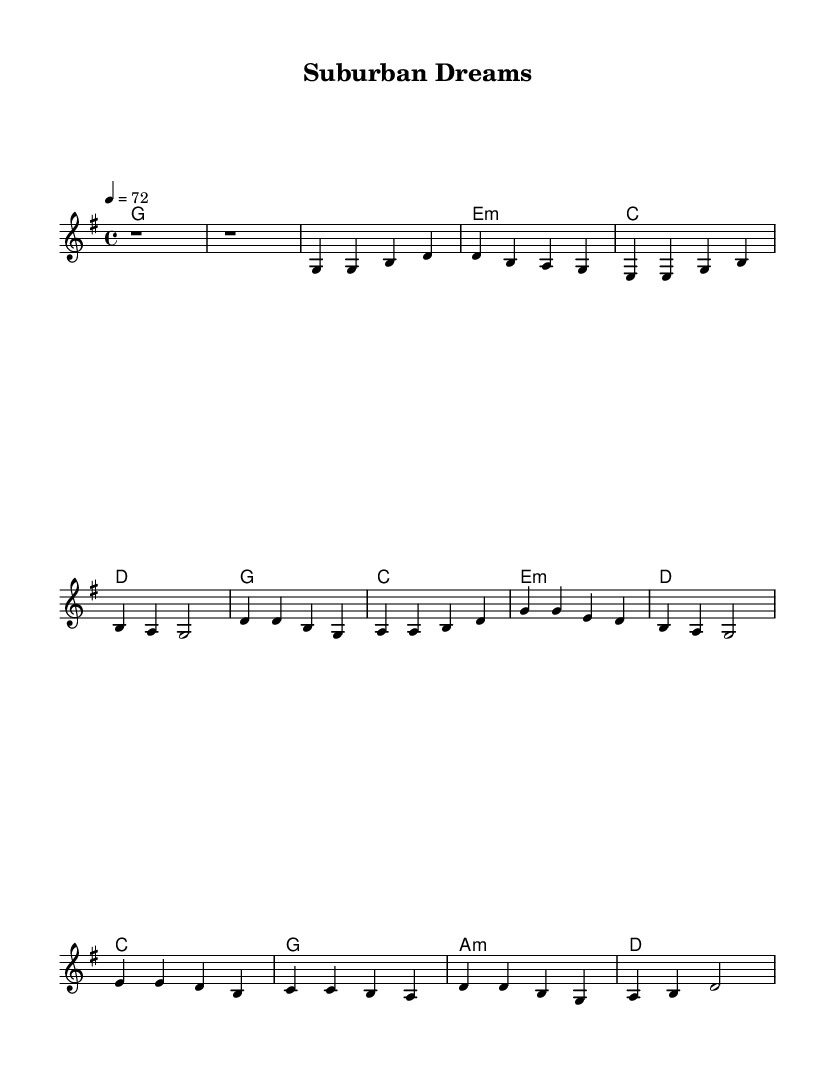what is the key signature of this music? The key signature is indicated by the presence of the G major key, which has one sharp (F#). This is seen at the beginning of the score.
Answer: G major what is the time signature of this sheet music? The time signature is determined by the notation shown at the beginning of the score, which displays 4/4. This indicates four beats per measure.
Answer: 4/4 what is the tempo marking of this piece? The tempo marking appears as 4 = 72, indicating that there are 72 beats in one minute at a quarter note count. This is also seen near the beginning of the score.
Answer: 72 which section of the music is represented by the intro? The intro is indicated by the initial two measures of rests, which is shown at the beginning of the melody.
Answer: two measures of rests how many bars are in the chorus section? To determine the number of bars in the chorus, we count the measures labeled in the music, which consists of four distinct measures written for the chorus.
Answer: 4 what is the relationship between the first and last chords in the song? The first chord is G major, and the last chord is also G major. Since both the beginning and conclusion of the piece are anchored by the same chord, it signifies resolution and completeness in the musical context.
Answer: same chord what type of themes are presented in this country rock ballad? The themes in this piece focus on middle-class struggles and aspirations, which are typical in country rock, often reflected in storytelling lyrics that resonate with everyday life experiences.
Answer: middle-class struggles and aspirations 